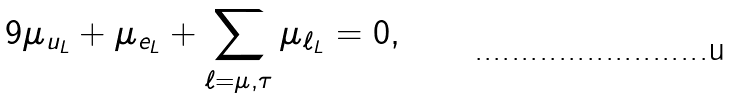<formula> <loc_0><loc_0><loc_500><loc_500>9 \mu _ { u _ { L } } + \mu _ { e _ { L } } + \sum _ { \ell = \mu , \tau } \mu _ { \ell _ { L } } = 0 ,</formula> 